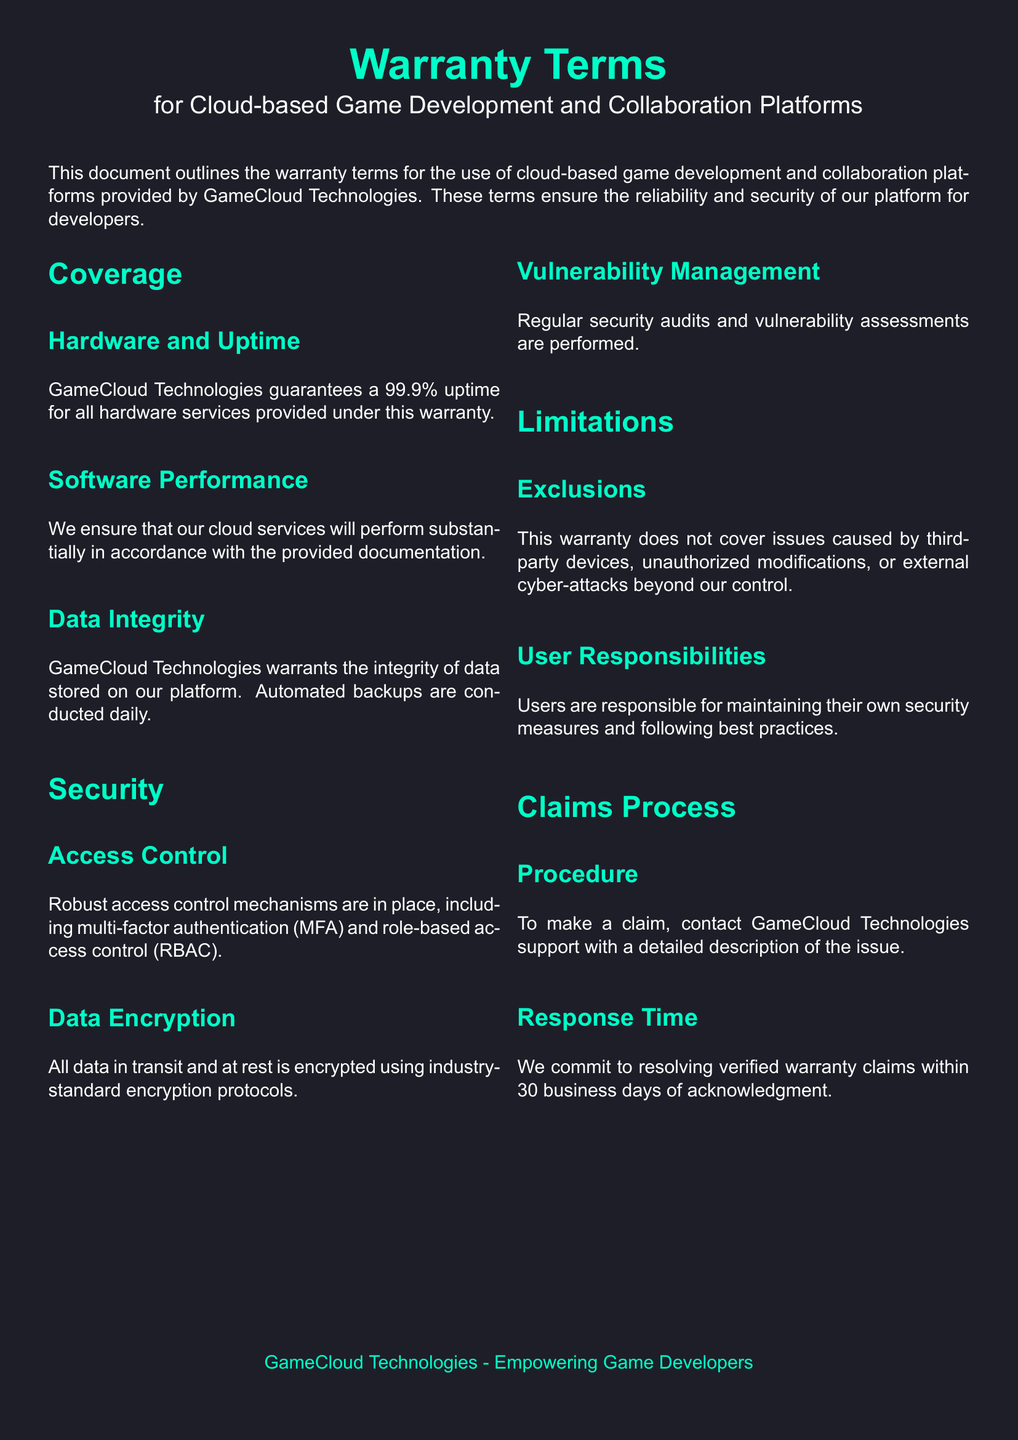What is the uptime guarantee? The document states that GameCloud Technologies guarantees a 99.9% uptime for all hardware services.
Answer: 99.9% What does the warranty cover regarding data? The warranty outlines that GameCloud Technologies warrants the integrity of data stored on its platform and conducts automated backups daily.
Answer: Data integrity What security measure includes role-based elements? The warranty mentions robust access control mechanisms, including role-based access control (RBAC).
Answer: Role-based access control What is not covered by the warranty? The document indicates that issues caused by third-party devices, unauthorized modifications, or external cyber-attacks are not covered under the warranty.
Answer: Exclusions What is the response time for verified warranty claims? According to the claims process outlined, GameCloud Technologies commits to resolving verified warranty claims within 30 business days.
Answer: 30 business days What should users maintain according to their responsibilities? The document specifies that users are responsible for maintaining their own security measures and following best practices.
Answer: Security measures What encryption is used for data? The document states that all data in transit and at rest is encrypted using industry-standard encryption protocols.
Answer: Industry-standard How often are security audits conducted? The document mentions that regular security audits and vulnerability assessments are performed.
Answer: Regularly 